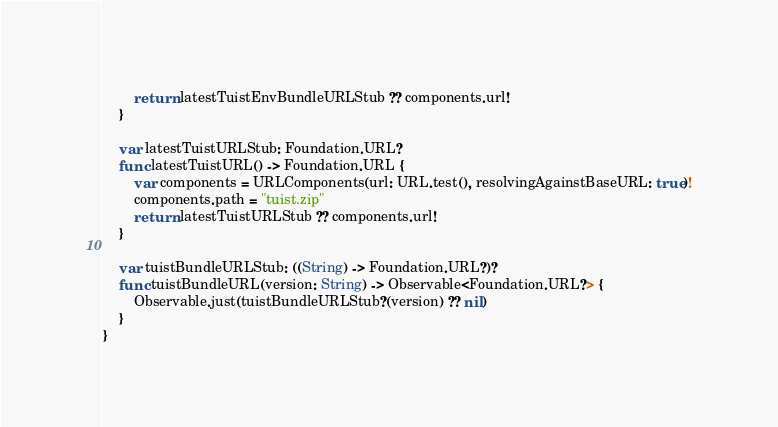Convert code to text. <code><loc_0><loc_0><loc_500><loc_500><_Swift_>        return latestTuistEnvBundleURLStub ?? components.url!
    }

    var latestTuistURLStub: Foundation.URL?
    func latestTuistURL() -> Foundation.URL {
        var components = URLComponents(url: URL.test(), resolvingAgainstBaseURL: true)!
        components.path = "tuist.zip"
        return latestTuistURLStub ?? components.url!
    }

    var tuistBundleURLStub: ((String) -> Foundation.URL?)?
    func tuistBundleURL(version: String) -> Observable<Foundation.URL?> {
        Observable.just(tuistBundleURLStub?(version) ?? nil)
    }
}
</code> 